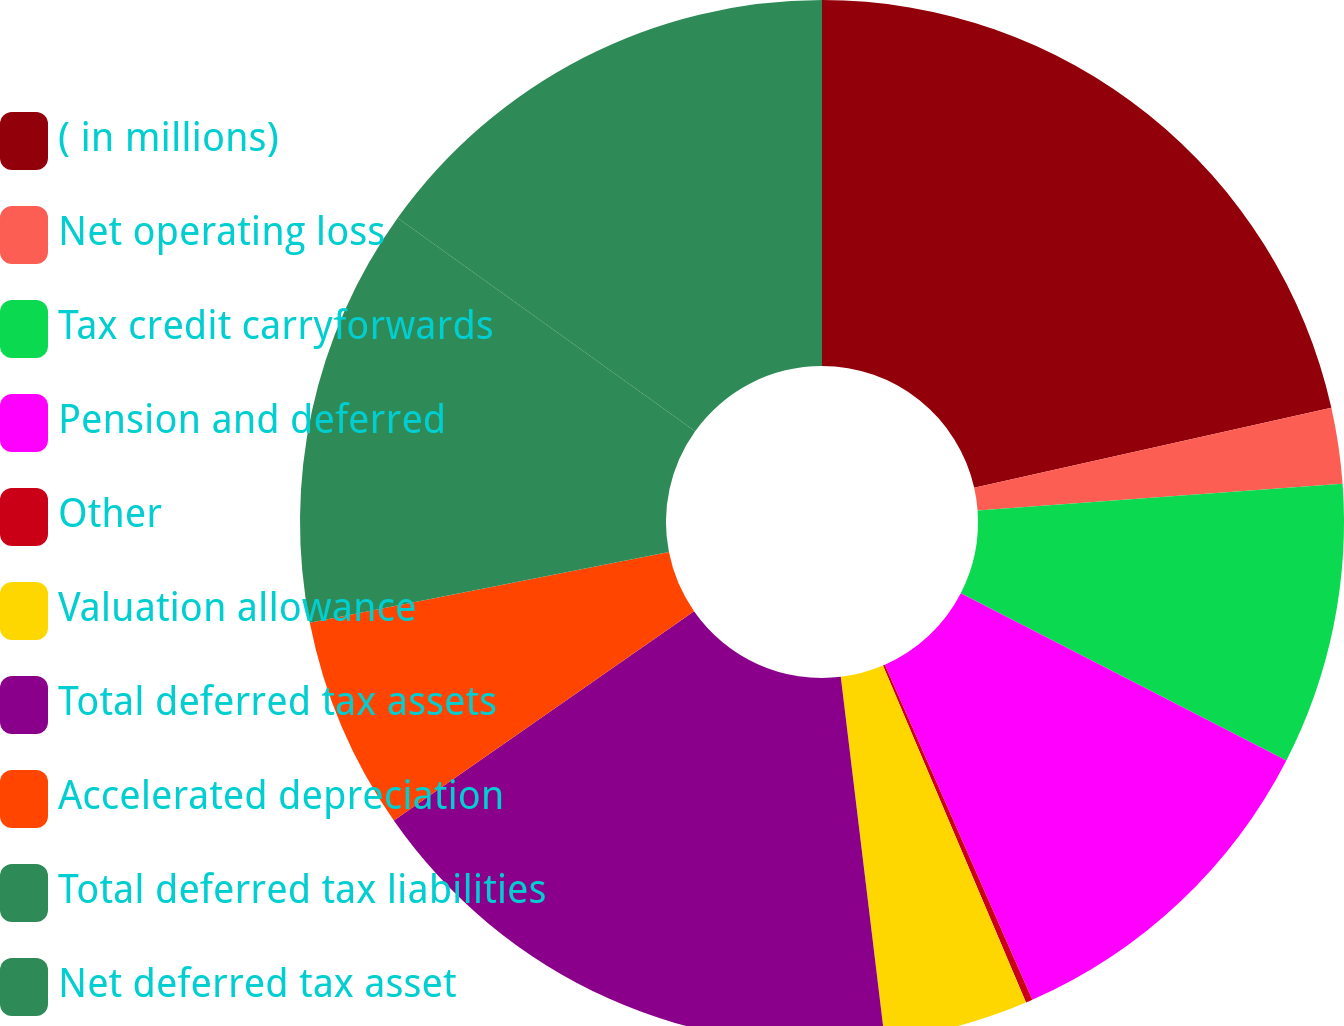<chart> <loc_0><loc_0><loc_500><loc_500><pie_chart><fcel>( in millions)<fcel>Net operating loss<fcel>Tax credit carryforwards<fcel>Pension and deferred<fcel>Other<fcel>Valuation allowance<fcel>Total deferred tax assets<fcel>Accelerated depreciation<fcel>Total deferred tax liabilities<fcel>Net deferred tax asset<nl><fcel>21.49%<fcel>2.34%<fcel>8.72%<fcel>10.85%<fcel>0.21%<fcel>4.47%<fcel>17.23%<fcel>6.6%<fcel>12.98%<fcel>15.11%<nl></chart> 